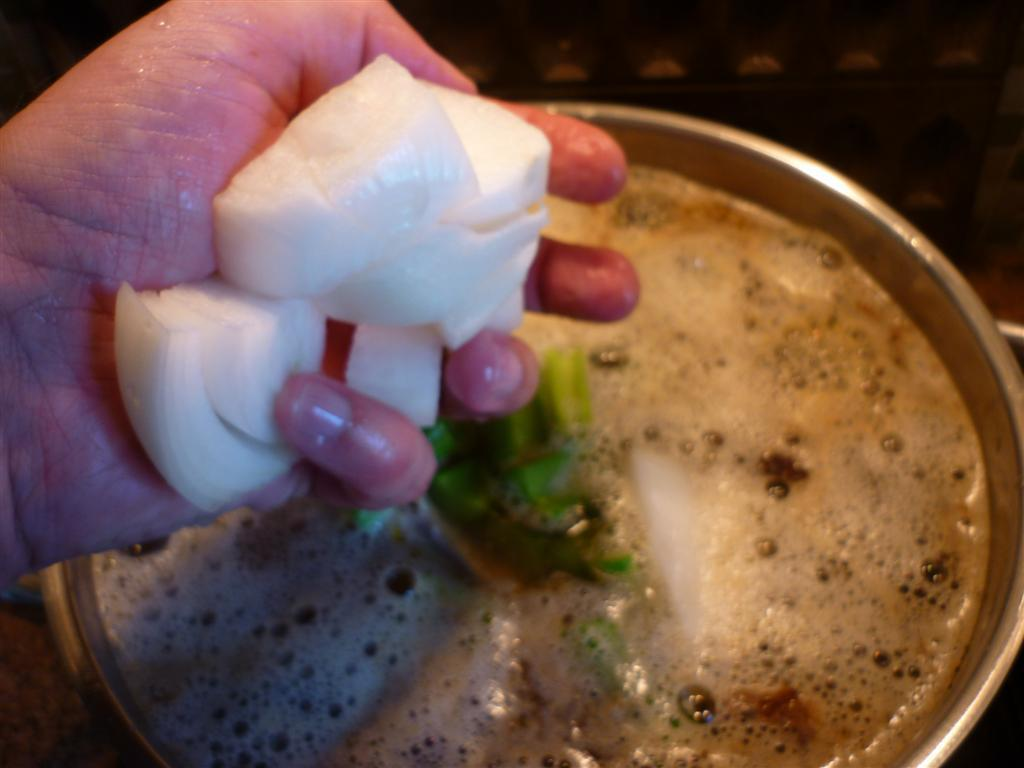What is inside the steel container in the image? There is coffee inside the steel container in the image. Can you describe the person holding an item in the image? The person is holding a white-colored food item in the image. How many cows are visible in the image? There are no cows present in the image. What type of bird can be seen perched on the person's shoulder in the image? There is no bird, specifically a robin, present in the image. 